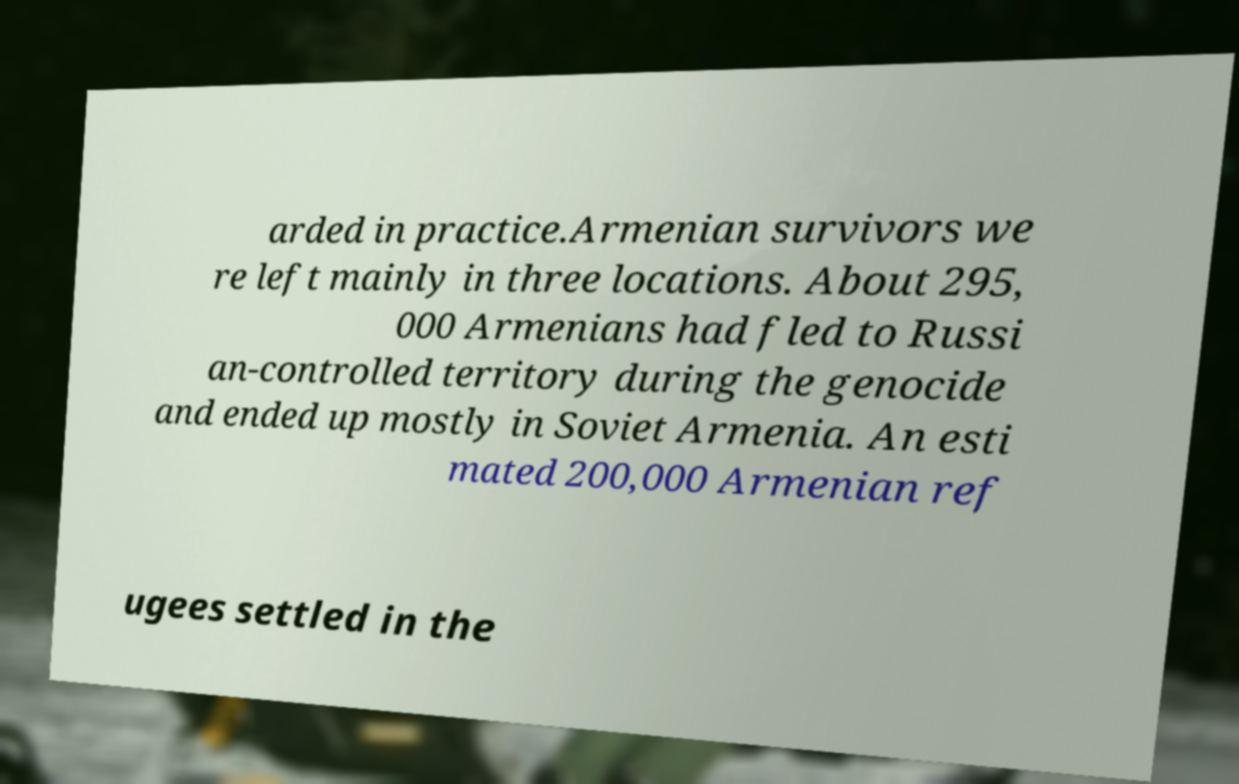Can you read and provide the text displayed in the image?This photo seems to have some interesting text. Can you extract and type it out for me? arded in practice.Armenian survivors we re left mainly in three locations. About 295, 000 Armenians had fled to Russi an-controlled territory during the genocide and ended up mostly in Soviet Armenia. An esti mated 200,000 Armenian ref ugees settled in the 